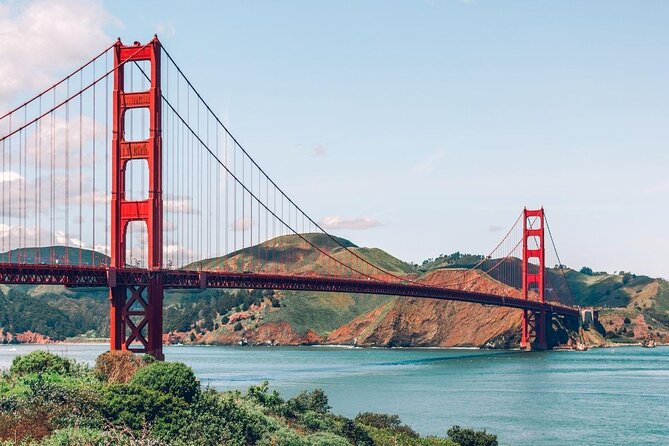This image seems to capture the daily life around the bridge. Can you describe a typical day in San Francisco with the Golden Gate Bridge in the background? A typical day in San Francisco with the Golden Gate Bridge as a backdrop begins with the early morning fog rolling in, shrouding the city in a mystical haze. Commuters start their day crossing the bridge, a rhythm of cars moving steadily against the soft hues of dawn. As the fog lifts, joggers and cyclists flock to the bridge, taking advantage of the cool, fresh air and the stunning views. By mid-morning, tourists gather, cameras in hand, eager to capture the iconic bridge in its full glory. The bustling Marina district hosts coffee shops buzzing with activity, while nearby parks see families and friends enjoying picnics. As the day progresses, sailboats and ferries traverse the bay beneath the bridge, adding to the lively scene. By evening, the bridge is bathed in the golden glow of the setting sun, a picture-perfect moment that marks the end of the day for locals and tourists alike. The bridge, standing ever-watchful, seamlessly blends into the vibrant daily life of San Francisco. And how about a quiet, solitary morning on the bridge? A quiet, solitary morning on the Golden Gate Bridge offers a serene and reflective experience. As the first light of dawn breaks, the bridge is enveloped in a tranquil stillness, with only the distant sound of waves lapping against the pillars. The air is fresh and crisp, filling the lungs with a sense of renewal. Few people are around, perhaps a lone jogger or an early morning fisherman casting a line into the bay. The fog begins to dissipate, revealing the expansive view of the city and surrounding hills. In this quiet moment, the bridge feels almost ethereal, a silent guardian of the city waking up to a new day. This solitude offers a chance to connect with the bridge on a personal level, appreciating its grandeur and the calmness it can bestow amid the usual hustle and bustle. 